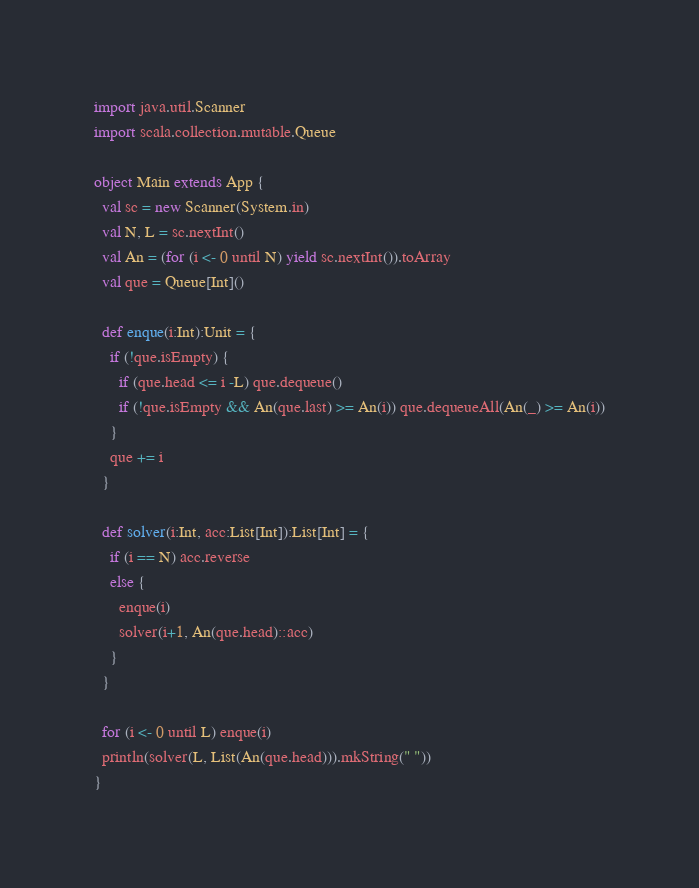Convert code to text. <code><loc_0><loc_0><loc_500><loc_500><_Scala_>import java.util.Scanner
import scala.collection.mutable.Queue

object Main extends App { 
  val sc = new Scanner(System.in)
  val N, L = sc.nextInt()
  val An = (for (i <- 0 until N) yield sc.nextInt()).toArray
  val que = Queue[Int]()

  def enque(i:Int):Unit = {
    if (!que.isEmpty) {
      if (que.head <= i -L) que.dequeue()
      if (!que.isEmpty && An(que.last) >= An(i)) que.dequeueAll(An(_) >= An(i))
    }
    que += i
  }

  def solver(i:Int, acc:List[Int]):List[Int] = {
    if (i == N) acc.reverse
    else {
      enque(i)
      solver(i+1, An(que.head)::acc)
    } 
  }

  for (i <- 0 until L) enque(i)
  println(solver(L, List(An(que.head))).mkString(" "))
}

</code> 